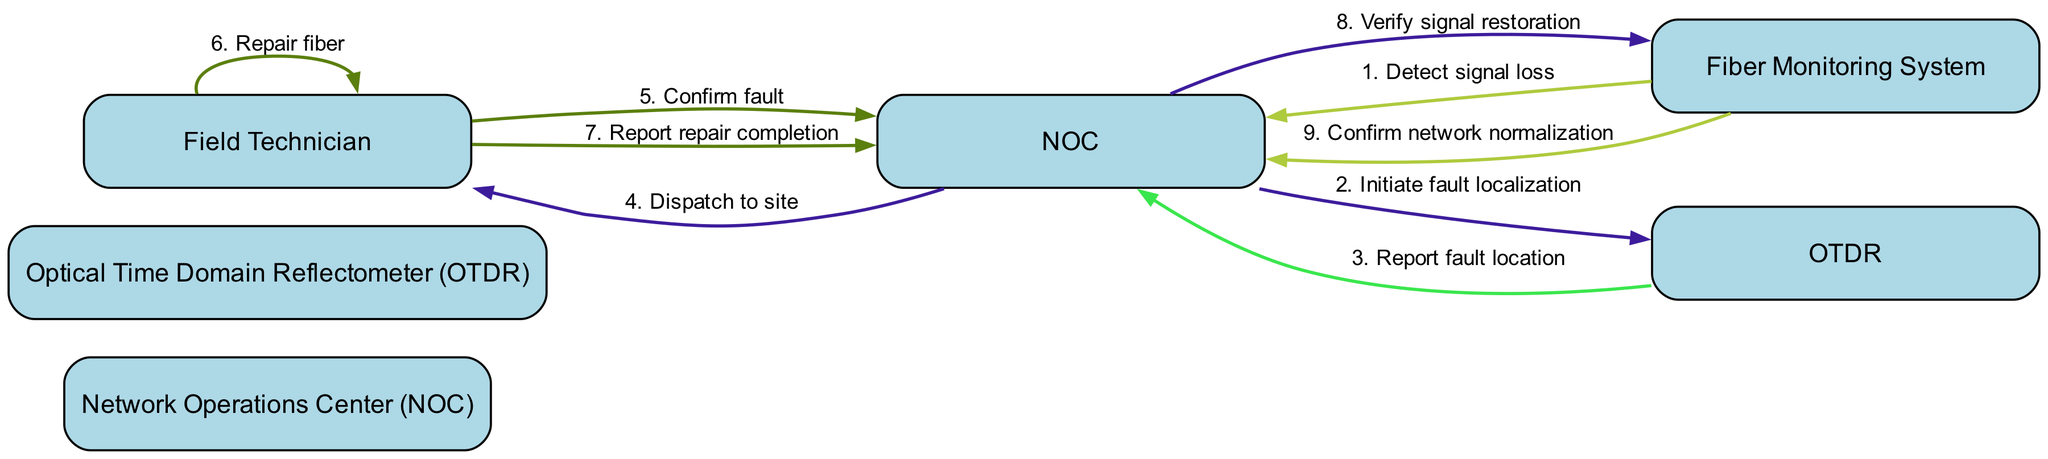What is the first action in the sequence? The first action in the sequence is performed by the Fiber Monitoring System, which detects signal loss and notifies the Network Operations Center.
Answer: Detect signal loss How many actors are involved in this sequence diagram? The diagram lists four actors: Network Operations Center, Optical Time Domain Reflectometer, Field Technician, and Fiber Monitoring System.
Answer: Four What message does the NOC send to the OTDR? The NOC sends the message to initiate fault localization to the OTDR in response to the detected signal loss.
Answer: Initiate fault localization Which actor confirms the fault before repair? The Field Technician is the actor who confirms the fault after being dispatched to the site by the NOC.
Answer: Field Technician What is the last message sent in the sequence? The last message sent in the sequence is from the Fiber Monitoring System to the NOC, confirming network normalization after repairs have been executed.
Answer: Confirm network normalization What is the relationship between the Field Technician and the NOC? The Field Technician communicates back to the NOC to confirm the fault and report the completion of repairs, indicating a support relationship in the sequence of actions.
Answer: Support relationship What happens after the Field Technician repairs the fiber? After the Field Technician repairs the fiber, they report back to the NOC to indicate that the repair is complete, which is essential for verifying service restoration.
Answer: Report repair completion How many messages are exchanged before the network is confirmed to be normalized? A total of eight messages are exchanged in the sequence before the network is confirmed to be normalized, which includes fault detection, localization, repair, and verification steps.
Answer: Eight 